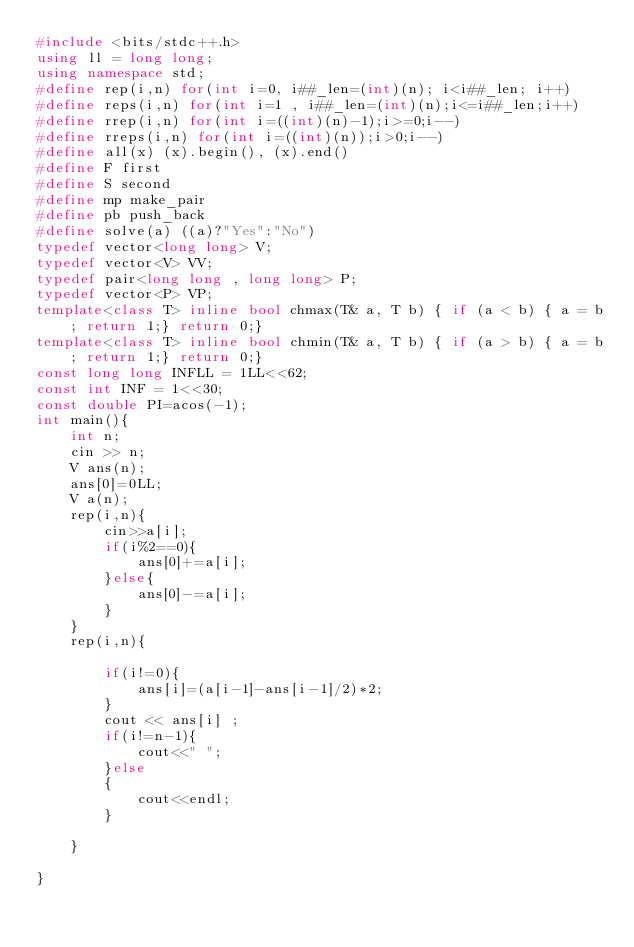Convert code to text. <code><loc_0><loc_0><loc_500><loc_500><_C++_>#include <bits/stdc++.h>
using ll = long long;
using namespace std;
#define rep(i,n) for(int i=0, i##_len=(int)(n); i<i##_len; i++)
#define reps(i,n) for(int i=1 , i##_len=(int)(n);i<=i##_len;i++)
#define rrep(i,n) for(int i=((int)(n)-1);i>=0;i--)
#define rreps(i,n) for(int i=((int)(n));i>0;i--)
#define all(x) (x).begin(), (x).end()
#define F first
#define S second
#define mp make_pair
#define pb push_back
#define solve(a) ((a)?"Yes":"No")
typedef vector<long long> V;
typedef vector<V> VV;
typedef pair<long long , long long> P;
typedef vector<P> VP;
template<class T> inline bool chmax(T& a, T b) { if (a < b) { a = b; return 1;} return 0;}
template<class T> inline bool chmin(T& a, T b) { if (a > b) { a = b; return 1;} return 0;}
const long long INFLL = 1LL<<62;
const int INF = 1<<30;
const double PI=acos(-1);
int main(){
	int n;
	cin >> n;
	V ans(n);
	ans[0]=0LL;
	V a(n);
	rep(i,n){
		cin>>a[i];
		if(i%2==0){
			ans[0]+=a[i];
		}else{
			ans[0]-=a[i];
		}
	}
	rep(i,n){
	
		if(i!=0){
			ans[i]=(a[i-1]-ans[i-1]/2)*2;
		}
		cout << ans[i] ;
		if(i!=n-1){
			cout<<" ";
		}else
		{
			cout<<endl;
		}
		
	}
	
}</code> 